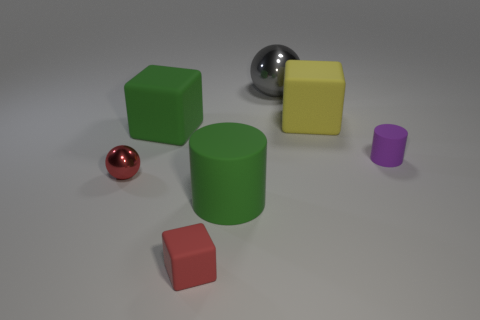There is a cylinder right of the big object to the right of the large ball; what size is it?
Make the answer very short. Small. There is a cube that is both right of the big green cube and behind the red rubber object; what color is it?
Give a very brief answer. Yellow. There is a gray sphere that is the same size as the green block; what is it made of?
Give a very brief answer. Metal. How many other things are there of the same material as the large green cylinder?
Provide a short and direct response. 4. Does the ball in front of the yellow block have the same color as the small rubber object that is in front of the red shiny thing?
Provide a succinct answer. Yes. There is a metallic object in front of the metallic thing behind the green block; what is its shape?
Ensure brevity in your answer.  Sphere. How many other things are there of the same color as the small ball?
Your answer should be compact. 1. Is the material of the cube to the right of the large gray sphere the same as the small red object that is to the left of the small rubber block?
Provide a succinct answer. No. There is a cube left of the small red cube; what size is it?
Provide a short and direct response. Large. There is another thing that is the same shape as the large metallic thing; what material is it?
Your answer should be very brief. Metal. 